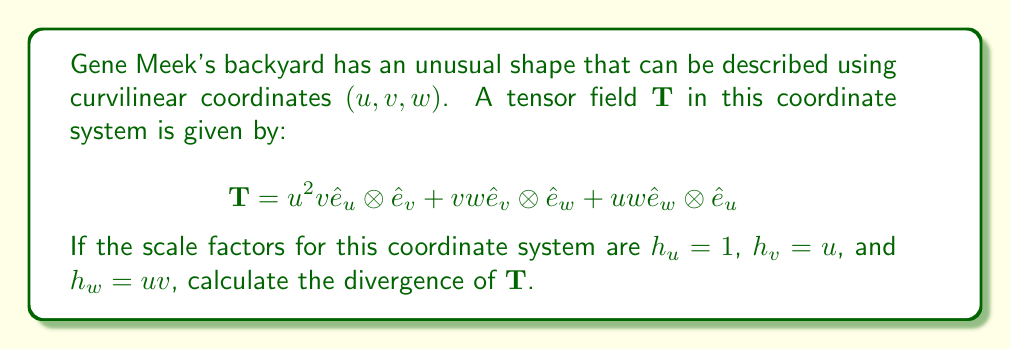Could you help me with this problem? To calculate the divergence of a tensor field in curvilinear coordinates, we use the formula:

$$\nabla \cdot \mathbf{T} = \frac{1}{h_1h_2h_3}\left[\frac{\partial}{\partial x^1}(h_2h_3T^{11}) + \frac{\partial}{\partial x^2}(h_1h_3T^{22}) + \frac{\partial}{\partial x^3}(h_1h_2T^{33})\right]$$

Where $(x^1, x^2, x^3)$ correspond to $(u, v, w)$ in our case.

Step 1: Identify the components and scale factors
$T^{11} = 0$, $T^{22} = 0$, $T^{33} = 0$
$h_1 = h_u = 1$, $h_2 = h_v = u$, $h_3 = h_w = uv$

Step 2: Simplify the divergence formula
Since $T^{11} = T^{22} = T^{33} = 0$, the divergence formula simplifies to:

$$\nabla \cdot \mathbf{T} = \frac{1}{h_1h_2h_3}\left[\frac{\partial}{\partial u}(h_2h_3T^{12}) + \frac{\partial}{\partial v}(h_1h_3T^{23}) + \frac{\partial}{\partial w}(h_1h_2T^{31})\right]$$

Step 3: Substitute the values
$T^{12} = u^2v$, $T^{23} = vw$, $T^{31} = uw$

$$\nabla \cdot \mathbf{T} = \frac{1}{1 \cdot u \cdot uv}\left[\frac{\partial}{\partial u}(u \cdot uv \cdot u^2v) + \frac{\partial}{\partial v}(1 \cdot uv \cdot vw) + \frac{\partial}{\partial w}(1 \cdot u \cdot uw)\right]$$

Step 4: Simplify and calculate derivatives
$$\nabla \cdot \mathbf{T} = \frac{1}{u^2v}\left[\frac{\partial}{\partial u}(u^4v^2) + \frac{\partial}{\partial v}(uv^2w) + \frac{\partial}{\partial w}(u^2w)\right]$$

$$\nabla \cdot \mathbf{T} = \frac{1}{u^2v}\left[4u^3v^2 + uv^2w + u^2\right]$$

Step 5: Simplify the final expression
$$\nabla \cdot \mathbf{T} = 4uv + \frac{vw}{u} + \frac{1}{v}$$
Answer: $4uv + \frac{vw}{u} + \frac{1}{v}$ 